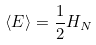<formula> <loc_0><loc_0><loc_500><loc_500>\langle E \rangle = \frac { 1 } { 2 } H _ { N }</formula> 